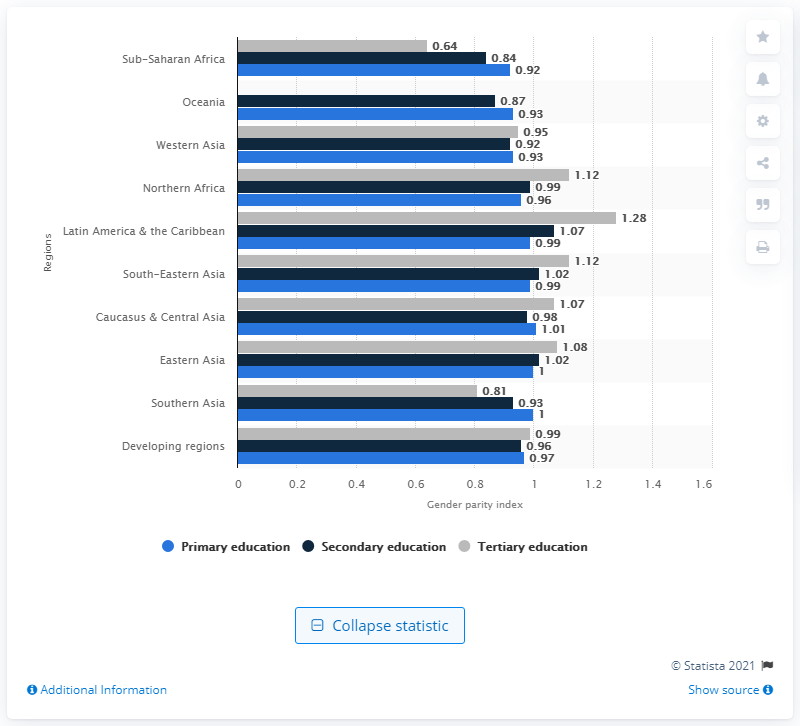Identify some key points in this picture. The GPI (Genuine Progress Indicator) score for tertiary education in Eastern Asia in 2012 was 1.08, indicating a positive trend in genuine progress. 